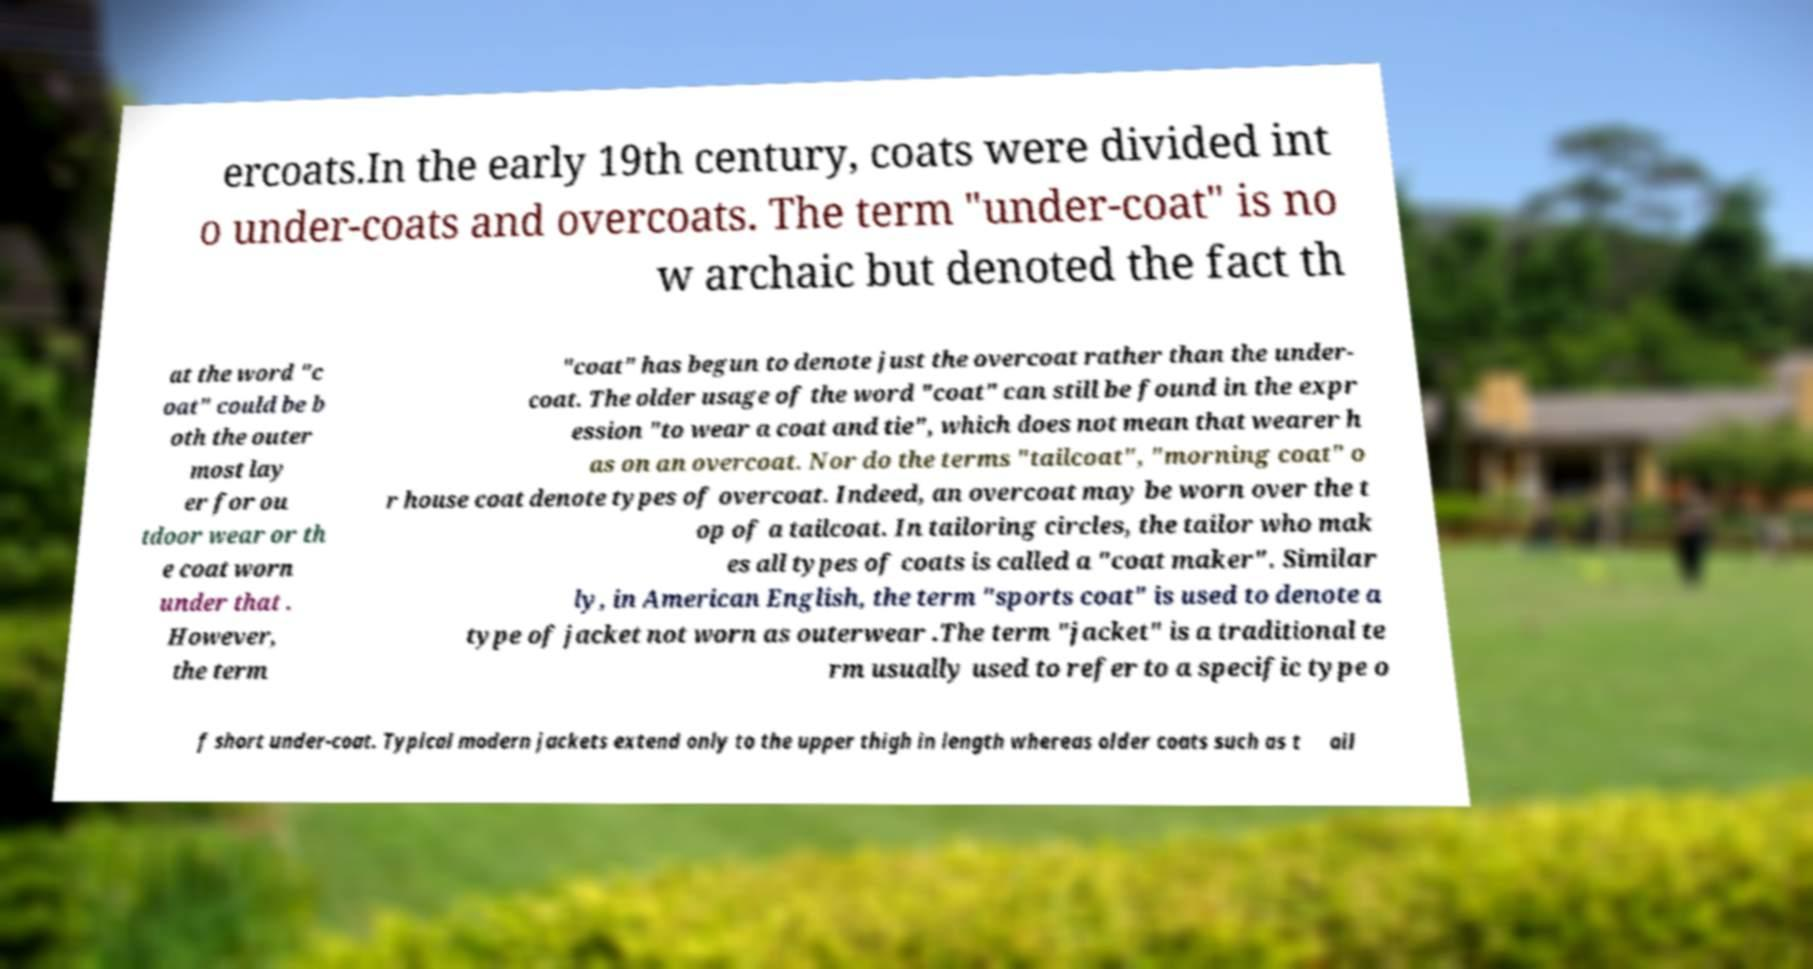There's text embedded in this image that I need extracted. Can you transcribe it verbatim? ercoats.In the early 19th century, coats were divided int o under-coats and overcoats. The term "under-coat" is no w archaic but denoted the fact th at the word "c oat" could be b oth the outer most lay er for ou tdoor wear or th e coat worn under that . However, the term "coat" has begun to denote just the overcoat rather than the under- coat. The older usage of the word "coat" can still be found in the expr ession "to wear a coat and tie", which does not mean that wearer h as on an overcoat. Nor do the terms "tailcoat", "morning coat" o r house coat denote types of overcoat. Indeed, an overcoat may be worn over the t op of a tailcoat. In tailoring circles, the tailor who mak es all types of coats is called a "coat maker". Similar ly, in American English, the term "sports coat" is used to denote a type of jacket not worn as outerwear .The term "jacket" is a traditional te rm usually used to refer to a specific type o f short under-coat. Typical modern jackets extend only to the upper thigh in length whereas older coats such as t ail 